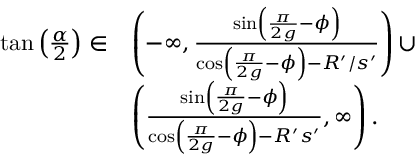<formula> <loc_0><loc_0><loc_500><loc_500>\begin{array} { r l } { \tan \left ( \frac { \alpha } { 2 } \right ) \in } & { \left ( - \infty , \frac { \sin \left ( \frac { \pi } { 2 g } - \phi \right ) } { \cos \left ( \frac { \pi } { 2 g } - \phi \right ) - R ^ { \prime } / s ^ { \prime } } \right ) \cup } \\ & { \left ( \frac { \sin \left ( \frac { \pi } { 2 g } - \phi \right ) } { \cos \left ( \frac { \pi } { 2 g } - \phi \right ) - R ^ { \prime } s ^ { \prime } } , \infty \right ) . } \end{array}</formula> 